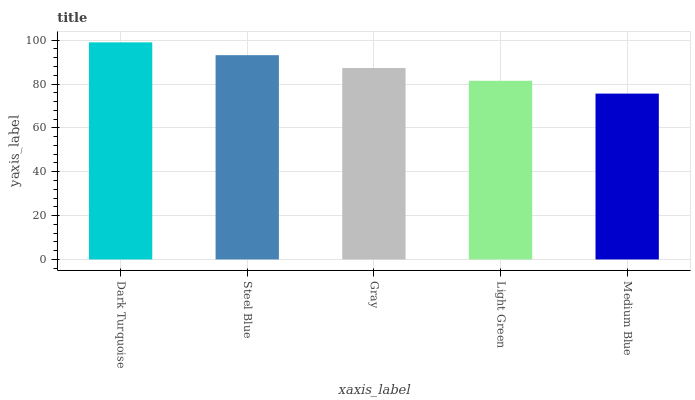Is Medium Blue the minimum?
Answer yes or no. Yes. Is Dark Turquoise the maximum?
Answer yes or no. Yes. Is Steel Blue the minimum?
Answer yes or no. No. Is Steel Blue the maximum?
Answer yes or no. No. Is Dark Turquoise greater than Steel Blue?
Answer yes or no. Yes. Is Steel Blue less than Dark Turquoise?
Answer yes or no. Yes. Is Steel Blue greater than Dark Turquoise?
Answer yes or no. No. Is Dark Turquoise less than Steel Blue?
Answer yes or no. No. Is Gray the high median?
Answer yes or no. Yes. Is Gray the low median?
Answer yes or no. Yes. Is Dark Turquoise the high median?
Answer yes or no. No. Is Steel Blue the low median?
Answer yes or no. No. 